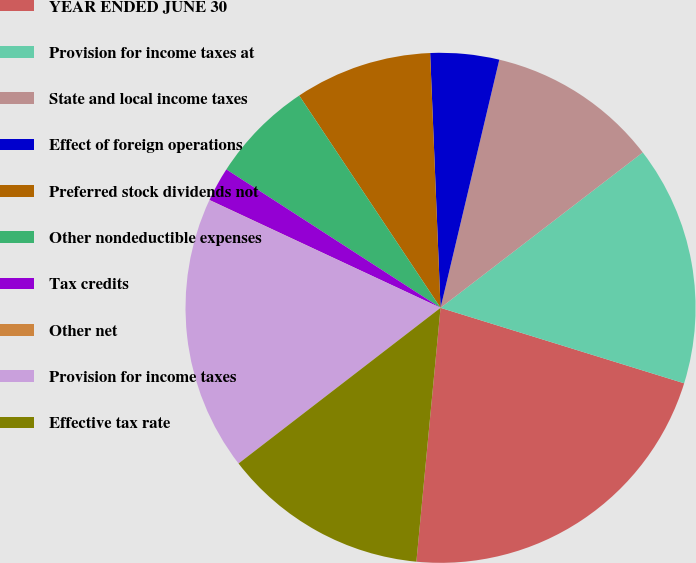Convert chart to OTSL. <chart><loc_0><loc_0><loc_500><loc_500><pie_chart><fcel>YEAR ENDED JUNE 30<fcel>Provision for income taxes at<fcel>State and local income taxes<fcel>Effect of foreign operations<fcel>Preferred stock dividends not<fcel>Other nondeductible expenses<fcel>Tax credits<fcel>Other net<fcel>Provision for income taxes<fcel>Effective tax rate<nl><fcel>21.73%<fcel>15.21%<fcel>10.87%<fcel>4.35%<fcel>8.7%<fcel>6.52%<fcel>2.18%<fcel>0.01%<fcel>17.39%<fcel>13.04%<nl></chart> 